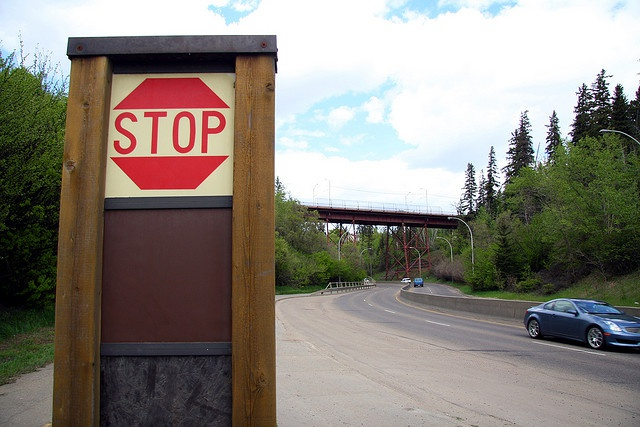Describe the objects in this image and their specific colors. I can see stop sign in lavender, beige, brown, and tan tones, car in lavender, black, navy, and gray tones, car in lavender, gray, blue, lightblue, and black tones, car in lavender, gray, lightgray, darkgray, and black tones, and car in lavender, gray, darkgray, and darkgreen tones in this image. 